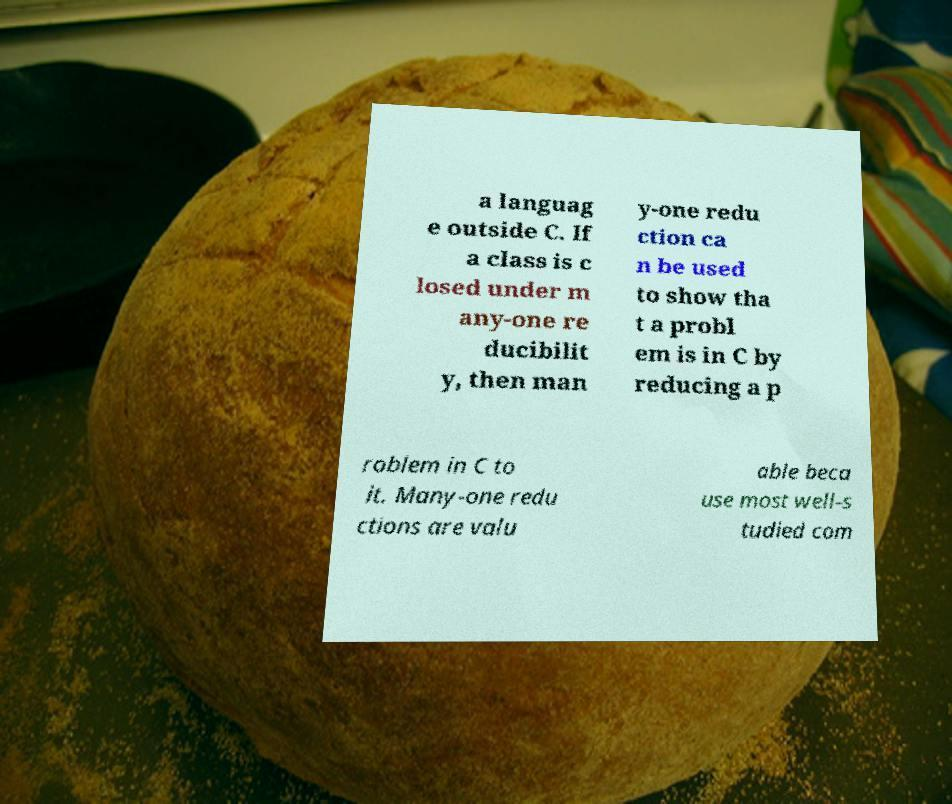What messages or text are displayed in this image? I need them in a readable, typed format. a languag e outside C. If a class is c losed under m any-one re ducibilit y, then man y-one redu ction ca n be used to show tha t a probl em is in C by reducing a p roblem in C to it. Many-one redu ctions are valu able beca use most well-s tudied com 